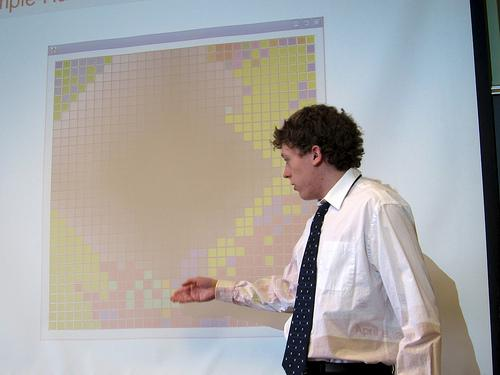Question: where is the man pointing?
Choices:
A. At the sky.
B. At the lady.
C. At a board.
D. At the cat.
Answer with the letter. Answer: C Question: what is behind the board?
Choices:
A. A wall.
B. A refrigerator.
C. A pole.
D. A tree.
Answer with the letter. Answer: A 